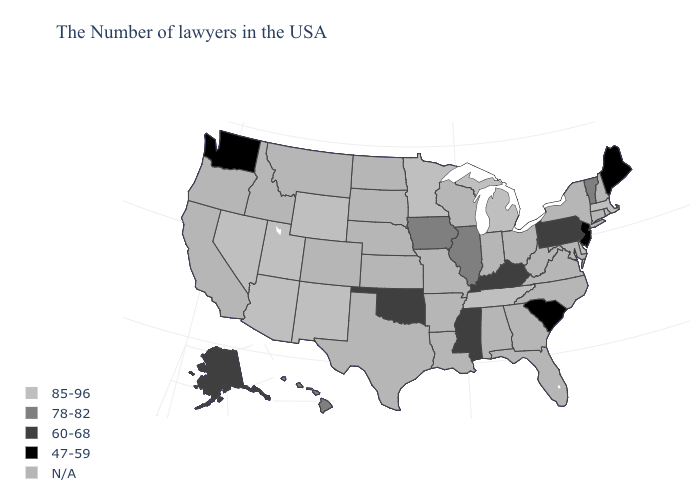Which states hav the highest value in the MidWest?
Write a very short answer. Michigan, Minnesota. What is the value of Kansas?
Concise answer only. N/A. Is the legend a continuous bar?
Short answer required. No. What is the lowest value in the South?
Concise answer only. 47-59. Among the states that border New Jersey , does Delaware have the highest value?
Concise answer only. Yes. What is the value of New Jersey?
Short answer required. 47-59. Name the states that have a value in the range 85-96?
Keep it brief. Massachusetts, Delaware, Michigan, Tennessee, Minnesota, Wyoming, New Mexico, Utah, Arizona, Nevada. Does South Carolina have the lowest value in the USA?
Answer briefly. Yes. What is the lowest value in the MidWest?
Short answer required. 78-82. Which states have the lowest value in the USA?
Be succinct. Maine, New Jersey, South Carolina, Washington. Name the states that have a value in the range N/A?
Answer briefly. Rhode Island, New Hampshire, Connecticut, New York, Maryland, Virginia, North Carolina, West Virginia, Ohio, Florida, Georgia, Indiana, Alabama, Wisconsin, Louisiana, Missouri, Arkansas, Kansas, Nebraska, Texas, South Dakota, North Dakota, Colorado, Montana, Idaho, California, Oregon. What is the value of Delaware?
Give a very brief answer. 85-96. Does South Carolina have the lowest value in the USA?
Write a very short answer. Yes. Name the states that have a value in the range N/A?
Quick response, please. Rhode Island, New Hampshire, Connecticut, New York, Maryland, Virginia, North Carolina, West Virginia, Ohio, Florida, Georgia, Indiana, Alabama, Wisconsin, Louisiana, Missouri, Arkansas, Kansas, Nebraska, Texas, South Dakota, North Dakota, Colorado, Montana, Idaho, California, Oregon. 